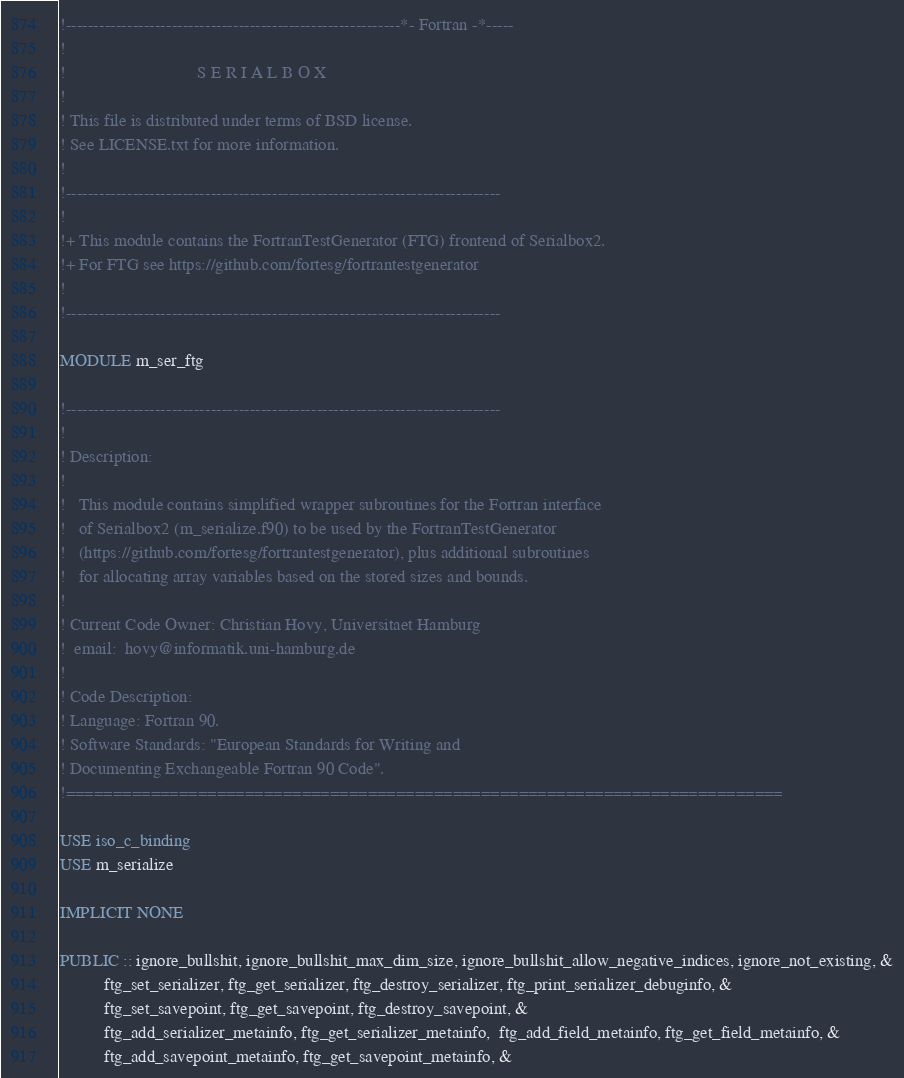<code> <loc_0><loc_0><loc_500><loc_500><_FORTRAN_>!------------------------------------------------------------*- Fortran -*-----
!
!                              S E R I A L B O X
!
! This file is distributed under terms of BSD license.
! See LICENSE.txt for more information.
!
!------------------------------------------------------------------------------
!
!+ This module contains the FortranTestGenerator (FTG) frontend of Serialbox2.
!+ For FTG see https://github.com/fortesg/fortrantestgenerator
!
!------------------------------------------------------------------------------

MODULE m_ser_ftg

!------------------------------------------------------------------------------
!
! Description:
!
!   This module contains simplified wrapper subroutines for the Fortran interface
!   of Serialbox2 (m_serialize.f90) to be used by the FortranTestGenerator
!   (https://github.com/fortesg/fortrantestgenerator), plus additional subroutines
!   for allocating array variables based on the stored sizes and bounds.
!
! Current Code Owner: Christian Hovy, Universitaet Hamburg
!  email:  hovy@informatik.uni-hamburg.de
!
! Code Description:
! Language: Fortran 90.
! Software Standards: "European Standards for Writing and
! Documenting Exchangeable Fortran 90 Code".
!============================================================================

USE iso_c_binding
USE m_serialize

IMPLICIT NONE

PUBLIC :: ignore_bullshit, ignore_bullshit_max_dim_size, ignore_bullshit_allow_negative_indices, ignore_not_existing, &
          ftg_set_serializer, ftg_get_serializer, ftg_destroy_serializer, ftg_print_serializer_debuginfo, &
          ftg_set_savepoint, ftg_get_savepoint, ftg_destroy_savepoint, &
          ftg_add_serializer_metainfo, ftg_get_serializer_metainfo,  ftg_add_field_metainfo, ftg_get_field_metainfo, &
          ftg_add_savepoint_metainfo, ftg_get_savepoint_metainfo, &</code> 